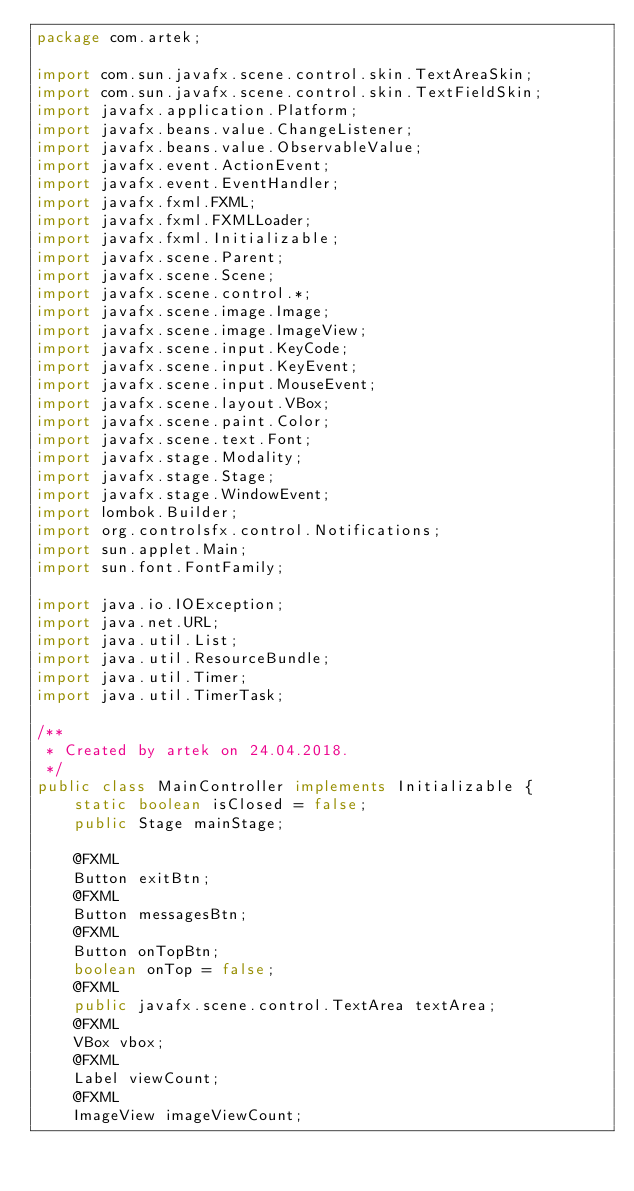Convert code to text. <code><loc_0><loc_0><loc_500><loc_500><_Java_>package com.artek;

import com.sun.javafx.scene.control.skin.TextAreaSkin;
import com.sun.javafx.scene.control.skin.TextFieldSkin;
import javafx.application.Platform;
import javafx.beans.value.ChangeListener;
import javafx.beans.value.ObservableValue;
import javafx.event.ActionEvent;
import javafx.event.EventHandler;
import javafx.fxml.FXML;
import javafx.fxml.FXMLLoader;
import javafx.fxml.Initializable;
import javafx.scene.Parent;
import javafx.scene.Scene;
import javafx.scene.control.*;
import javafx.scene.image.Image;
import javafx.scene.image.ImageView;
import javafx.scene.input.KeyCode;
import javafx.scene.input.KeyEvent;
import javafx.scene.input.MouseEvent;
import javafx.scene.layout.VBox;
import javafx.scene.paint.Color;
import javafx.scene.text.Font;
import javafx.stage.Modality;
import javafx.stage.Stage;
import javafx.stage.WindowEvent;
import lombok.Builder;
import org.controlsfx.control.Notifications;
import sun.applet.Main;
import sun.font.FontFamily;

import java.io.IOException;
import java.net.URL;
import java.util.List;
import java.util.ResourceBundle;
import java.util.Timer;
import java.util.TimerTask;

/**
 * Created by artek on 24.04.2018.
 */
public class MainController implements Initializable {
    static boolean isClosed = false;
    public Stage mainStage;

    @FXML
    Button exitBtn;
    @FXML
    Button messagesBtn;
    @FXML
    Button onTopBtn;
    boolean onTop = false;
    @FXML
    public javafx.scene.control.TextArea textArea;
    @FXML
    VBox vbox;
    @FXML
    Label viewCount;
    @FXML
    ImageView imageViewCount;
</code> 